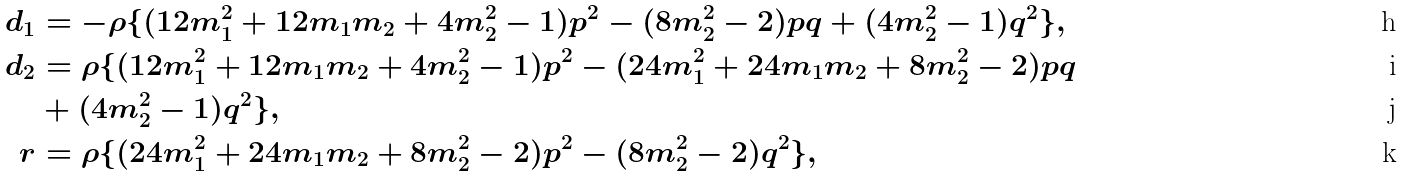Convert formula to latex. <formula><loc_0><loc_0><loc_500><loc_500>d _ { 1 } & = - \rho \{ ( 1 2 m _ { 1 } ^ { 2 } + 1 2 m _ { 1 } m _ { 2 } + 4 m _ { 2 } ^ { 2 } - 1 ) p ^ { 2 } - ( 8 m _ { 2 } ^ { 2 } - 2 ) p q + ( 4 m _ { 2 } ^ { 2 } - 1 ) q ^ { 2 } \} , \\ d _ { 2 } & = \rho \{ ( 1 2 m _ { 1 } ^ { 2 } + 1 2 m _ { 1 } m _ { 2 } + 4 m _ { 2 } ^ { 2 } - 1 ) p ^ { 2 } - ( 2 4 m _ { 1 } ^ { 2 } + 2 4 m _ { 1 } m _ { 2 } + 8 m _ { 2 } ^ { 2 } - 2 ) p q \\ & + ( 4 m _ { 2 } ^ { 2 } - 1 ) q ^ { 2 } \} , \\ r & = \rho \{ ( 2 4 m _ { 1 } ^ { 2 } + 2 4 m _ { 1 } m _ { 2 } + 8 m _ { 2 } ^ { 2 } - 2 ) p ^ { 2 } - ( 8 m _ { 2 } ^ { 2 } - 2 ) q ^ { 2 } \} ,</formula> 